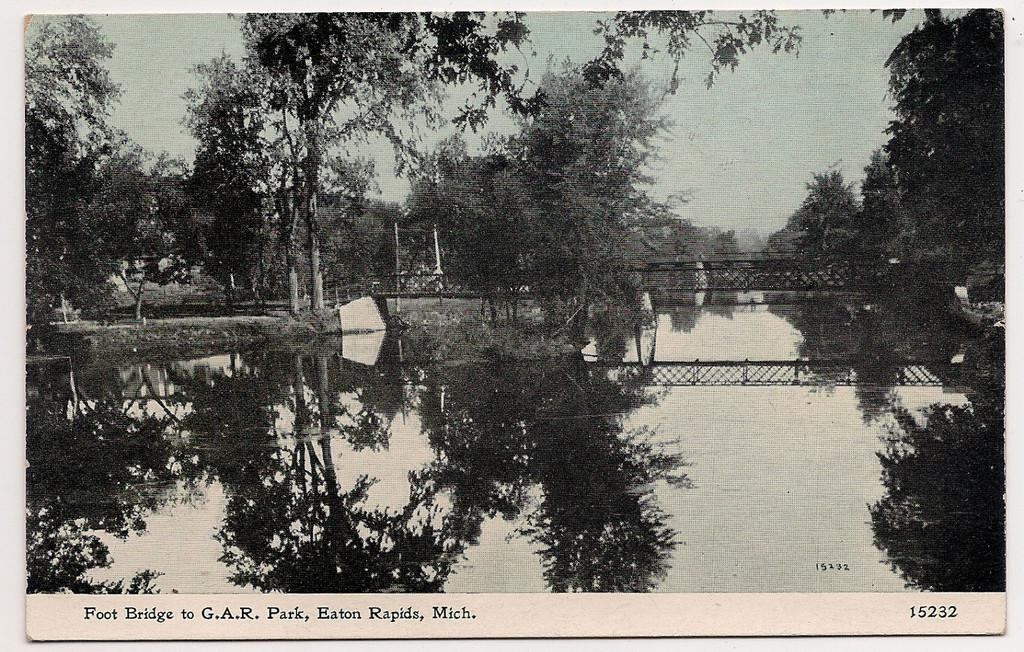What is the color scheme of the image? The image is black and white. What can be seen at the bottom of the image? There is water at the bottom of the image. What structure is located in the middle of the image? There is a bridge in the middle of the image. What type of vegetation is present on either side of the bridge? There are trees on either side of the bridge. What type of shade is provided by the trees on either side of the bridge? There is no mention of shade in the image, as it is black and white and does not depict shadows or sunlight. 